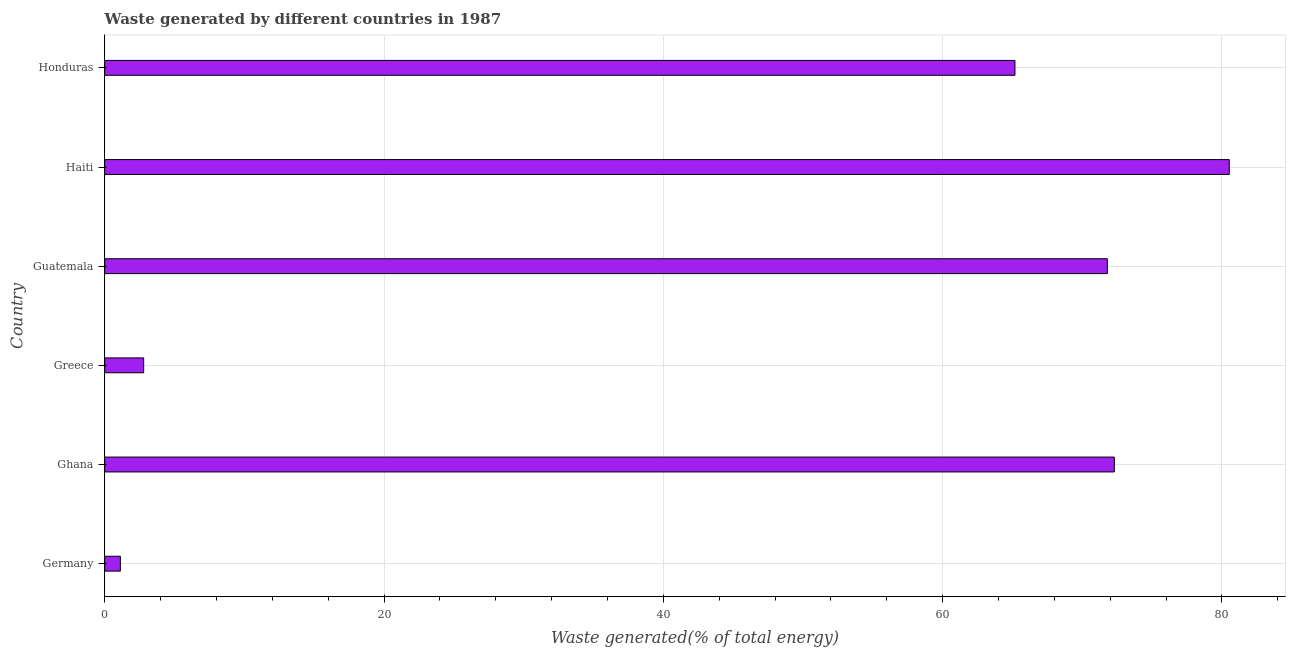Does the graph contain any zero values?
Make the answer very short. No. Does the graph contain grids?
Offer a very short reply. Yes. What is the title of the graph?
Ensure brevity in your answer.  Waste generated by different countries in 1987. What is the label or title of the X-axis?
Keep it short and to the point. Waste generated(% of total energy). What is the amount of waste generated in Haiti?
Your response must be concise. 80.53. Across all countries, what is the maximum amount of waste generated?
Make the answer very short. 80.53. Across all countries, what is the minimum amount of waste generated?
Ensure brevity in your answer.  1.12. In which country was the amount of waste generated maximum?
Offer a very short reply. Haiti. In which country was the amount of waste generated minimum?
Offer a very short reply. Germany. What is the sum of the amount of waste generated?
Your response must be concise. 293.72. What is the difference between the amount of waste generated in Greece and Guatemala?
Make the answer very short. -69.01. What is the average amount of waste generated per country?
Provide a short and direct response. 48.95. What is the median amount of waste generated?
Ensure brevity in your answer.  68.49. What is the ratio of the amount of waste generated in Germany to that in Haiti?
Your answer should be very brief. 0.01. Is the difference between the amount of waste generated in Ghana and Honduras greater than the difference between any two countries?
Keep it short and to the point. No. What is the difference between the highest and the second highest amount of waste generated?
Your response must be concise. 8.23. What is the difference between the highest and the lowest amount of waste generated?
Your answer should be compact. 79.41. In how many countries, is the amount of waste generated greater than the average amount of waste generated taken over all countries?
Keep it short and to the point. 4. How many bars are there?
Provide a short and direct response. 6. Are all the bars in the graph horizontal?
Make the answer very short. Yes. Are the values on the major ticks of X-axis written in scientific E-notation?
Provide a short and direct response. No. What is the Waste generated(% of total energy) of Germany?
Your answer should be compact. 1.12. What is the Waste generated(% of total energy) of Ghana?
Ensure brevity in your answer.  72.3. What is the Waste generated(% of total energy) in Greece?
Offer a terse response. 2.79. What is the Waste generated(% of total energy) in Guatemala?
Provide a succinct answer. 71.8. What is the Waste generated(% of total energy) of Haiti?
Provide a succinct answer. 80.53. What is the Waste generated(% of total energy) of Honduras?
Ensure brevity in your answer.  65.18. What is the difference between the Waste generated(% of total energy) in Germany and Ghana?
Make the answer very short. -71.18. What is the difference between the Waste generated(% of total energy) in Germany and Greece?
Offer a terse response. -1.67. What is the difference between the Waste generated(% of total energy) in Germany and Guatemala?
Your answer should be very brief. -70.68. What is the difference between the Waste generated(% of total energy) in Germany and Haiti?
Your answer should be compact. -79.41. What is the difference between the Waste generated(% of total energy) in Germany and Honduras?
Keep it short and to the point. -64.06. What is the difference between the Waste generated(% of total energy) in Ghana and Greece?
Offer a terse response. 69.51. What is the difference between the Waste generated(% of total energy) in Ghana and Guatemala?
Keep it short and to the point. 0.5. What is the difference between the Waste generated(% of total energy) in Ghana and Haiti?
Offer a very short reply. -8.23. What is the difference between the Waste generated(% of total energy) in Ghana and Honduras?
Keep it short and to the point. 7.12. What is the difference between the Waste generated(% of total energy) in Greece and Guatemala?
Offer a terse response. -69.01. What is the difference between the Waste generated(% of total energy) in Greece and Haiti?
Your answer should be very brief. -77.74. What is the difference between the Waste generated(% of total energy) in Greece and Honduras?
Keep it short and to the point. -62.39. What is the difference between the Waste generated(% of total energy) in Guatemala and Haiti?
Ensure brevity in your answer.  -8.73. What is the difference between the Waste generated(% of total energy) in Guatemala and Honduras?
Ensure brevity in your answer.  6.62. What is the difference between the Waste generated(% of total energy) in Haiti and Honduras?
Your response must be concise. 15.35. What is the ratio of the Waste generated(% of total energy) in Germany to that in Ghana?
Provide a succinct answer. 0.01. What is the ratio of the Waste generated(% of total energy) in Germany to that in Greece?
Offer a terse response. 0.4. What is the ratio of the Waste generated(% of total energy) in Germany to that in Guatemala?
Give a very brief answer. 0.02. What is the ratio of the Waste generated(% of total energy) in Germany to that in Haiti?
Provide a short and direct response. 0.01. What is the ratio of the Waste generated(% of total energy) in Germany to that in Honduras?
Offer a very short reply. 0.02. What is the ratio of the Waste generated(% of total energy) in Ghana to that in Greece?
Provide a succinct answer. 25.92. What is the ratio of the Waste generated(% of total energy) in Ghana to that in Guatemala?
Offer a terse response. 1.01. What is the ratio of the Waste generated(% of total energy) in Ghana to that in Haiti?
Your response must be concise. 0.9. What is the ratio of the Waste generated(% of total energy) in Ghana to that in Honduras?
Your answer should be very brief. 1.11. What is the ratio of the Waste generated(% of total energy) in Greece to that in Guatemala?
Provide a succinct answer. 0.04. What is the ratio of the Waste generated(% of total energy) in Greece to that in Haiti?
Make the answer very short. 0.04. What is the ratio of the Waste generated(% of total energy) in Greece to that in Honduras?
Provide a succinct answer. 0.04. What is the ratio of the Waste generated(% of total energy) in Guatemala to that in Haiti?
Provide a short and direct response. 0.89. What is the ratio of the Waste generated(% of total energy) in Guatemala to that in Honduras?
Keep it short and to the point. 1.1. What is the ratio of the Waste generated(% of total energy) in Haiti to that in Honduras?
Your answer should be very brief. 1.24. 